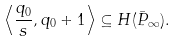<formula> <loc_0><loc_0><loc_500><loc_500>\left \langle \frac { q _ { 0 } } { s } , q _ { 0 } + 1 \right \rangle \subseteq H ( \bar { P } _ { \infty } ) .</formula> 